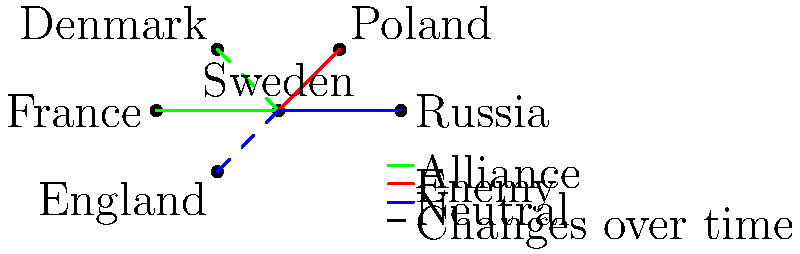Analyze the network diagram representing Sweden's changing alliances with other European powers during the 17th and 18th centuries. Which country, according to the diagram, shifted from being Sweden's enemy to becoming its ally? To answer this question, we need to examine the relationships depicted in the network diagram:

1. Sweden is at the center of the diagram, connected to other European powers.
2. The legend indicates that:
   - Green lines represent alliances
   - Red lines represent enemies
   - Blue lines represent neutral relationships
   - Dashed lines indicate changes over time

3. Examining the connections:
   - Denmark: Green dashed line, suggesting a shift towards alliance
   - Poland: Red line, indicating an enemy relationship
   - Russia: Blue line, indicating a neutral relationship
   - France: Green line, indicating an alliance
   - England: Blue dashed line, suggesting a shift in the neutral relationship

4. The question asks about a shift from enemy to ally. The only country that fits this description is Denmark.
   - The green dashed line to Denmark suggests it changed from another color (likely red, indicating an enemy) to green (indicating an ally).

5. This shift aligns with historical events:
   - Denmark and Sweden were long-standing rivals in the Baltic region.
   - After the Great Northern War (1700-1721), their relationship gradually improved.
   - By the late 18th century, they formed alliances against common threats, such as Russia.
Answer: Denmark 